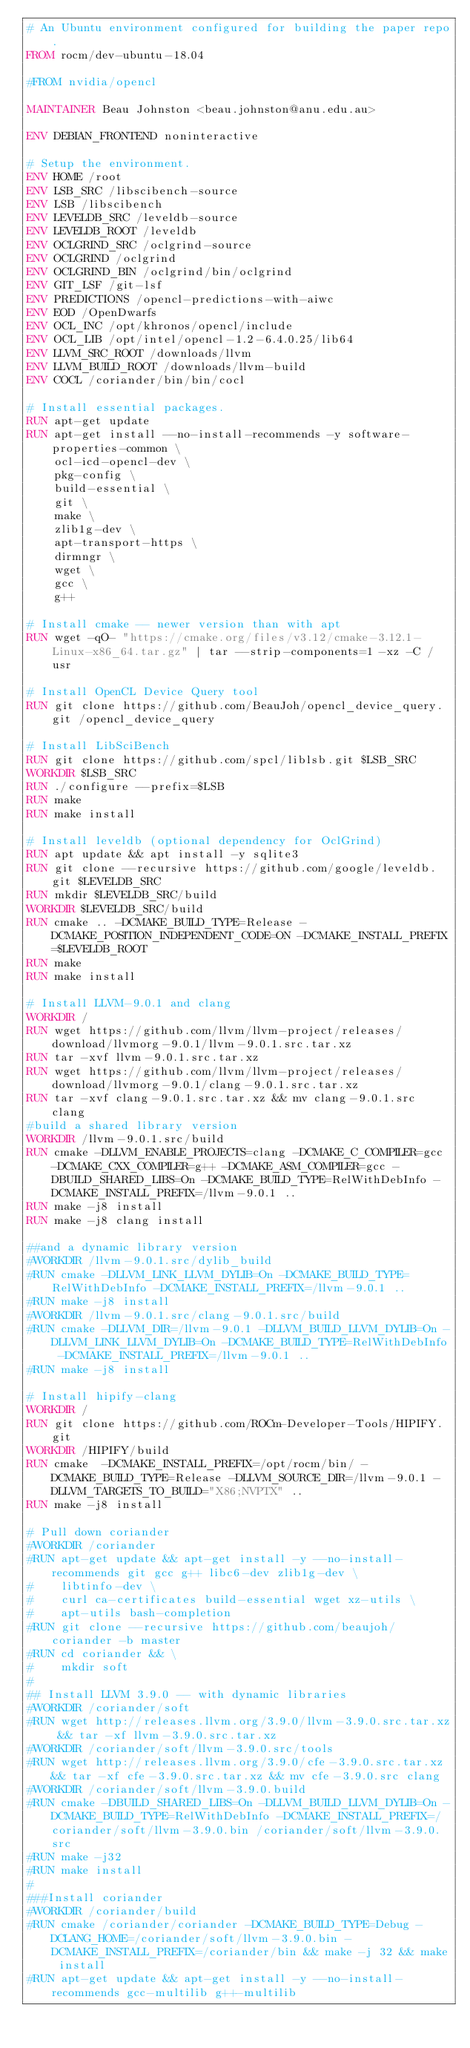<code> <loc_0><loc_0><loc_500><loc_500><_Dockerfile_># An Ubuntu environment configured for building the paper repo.
FROM rocm/dev-ubuntu-18.04

#FROM nvidia/opencl

MAINTAINER Beau Johnston <beau.johnston@anu.edu.au>

ENV DEBIAN_FRONTEND noninteractive

# Setup the environment.
ENV HOME /root
ENV LSB_SRC /libscibench-source
ENV LSB /libscibench
ENV LEVELDB_SRC /leveldb-source
ENV LEVELDB_ROOT /leveldb
ENV OCLGRIND_SRC /oclgrind-source
ENV OCLGRIND /oclgrind
ENV OCLGRIND_BIN /oclgrind/bin/oclgrind
ENV GIT_LSF /git-lsf
ENV PREDICTIONS /opencl-predictions-with-aiwc
ENV EOD /OpenDwarfs
ENV OCL_INC /opt/khronos/opencl/include
ENV OCL_LIB /opt/intel/opencl-1.2-6.4.0.25/lib64
ENV LLVM_SRC_ROOT /downloads/llvm
ENV LLVM_BUILD_ROOT /downloads/llvm-build
ENV COCL /coriander/bin/bin/cocl

# Install essential packages.
RUN apt-get update
RUN apt-get install --no-install-recommends -y software-properties-common \
    ocl-icd-opencl-dev \
    pkg-config \
    build-essential \
    git \
    make \
    zlib1g-dev \
    apt-transport-https \
    dirmngr \
    wget \
    gcc \
    g++

# Install cmake -- newer version than with apt
RUN wget -qO- "https://cmake.org/files/v3.12/cmake-3.12.1-Linux-x86_64.tar.gz" | tar --strip-components=1 -xz -C /usr

# Install OpenCL Device Query tool
RUN git clone https://github.com/BeauJoh/opencl_device_query.git /opencl_device_query

# Install LibSciBench
RUN git clone https://github.com/spcl/liblsb.git $LSB_SRC
WORKDIR $LSB_SRC
RUN ./configure --prefix=$LSB
RUN make
RUN make install

# Install leveldb (optional dependency for OclGrind)
RUN apt update && apt install -y sqlite3
RUN git clone --recursive https://github.com/google/leveldb.git $LEVELDB_SRC
RUN mkdir $LEVELDB_SRC/build
WORKDIR $LEVELDB_SRC/build
RUN cmake .. -DCMAKE_BUILD_TYPE=Release -DCMAKE_POSITION_INDEPENDENT_CODE=ON -DCMAKE_INSTALL_PREFIX=$LEVELDB_ROOT
RUN make
RUN make install

# Install LLVM-9.0.1 and clang
WORKDIR /
RUN wget https://github.com/llvm/llvm-project/releases/download/llvmorg-9.0.1/llvm-9.0.1.src.tar.xz
RUN tar -xvf llvm-9.0.1.src.tar.xz
RUN wget https://github.com/llvm/llvm-project/releases/download/llvmorg-9.0.1/clang-9.0.1.src.tar.xz
RUN tar -xvf clang-9.0.1.src.tar.xz && mv clang-9.0.1.src clang
#build a shared library version
WORKDIR /llvm-9.0.1.src/build
RUN cmake -DLLVM_ENABLE_PROJECTS=clang -DCMAKE_C_COMPILER=gcc -DCMAKE_CXX_COMPILER=g++ -DCMAKE_ASM_COMPILER=gcc -DBUILD_SHARED_LIBS=On -DCMAKE_BUILD_TYPE=RelWithDebInfo -DCMAKE_INSTALL_PREFIX=/llvm-9.0.1 ..
RUN make -j8 install
RUN make -j8 clang install

##and a dynamic library version
#WORKDIR /llvm-9.0.1.src/dylib_build
#RUN cmake -DLLVM_LINK_LLVM_DYLIB=On -DCMAKE_BUILD_TYPE=RelWithDebInfo -DCMAKE_INSTALL_PREFIX=/llvm-9.0.1 ..
#RUN make -j8 install
#WORKDIR /llvm-9.0.1.src/clang-9.0.1.src/build
#RUN cmake -DLLVM_DIR=/llvm-9.0.1 -DLLVM_BUILD_LLVM_DYLIB=On -DLLVM_LINK_LLVM_DYLIB=On -DCMAKE_BUILD_TYPE=RelWithDebInfo -DCMAKE_INSTALL_PREFIX=/llvm-9.0.1 ..
#RUN make -j8 install

# Install hipify-clang
WORKDIR /
RUN git clone https://github.com/ROCm-Developer-Tools/HIPIFY.git
WORKDIR /HIPIFY/build
RUN cmake  -DCMAKE_INSTALL_PREFIX=/opt/rocm/bin/ -DCMAKE_BUILD_TYPE=Release -DLLVM_SOURCE_DIR=/llvm-9.0.1 -DLLVM_TARGETS_TO_BUILD="X86;NVPTX" ..
RUN make -j8 install

# Pull down coriander
#WORKDIR /coriander
#RUN apt-get update && apt-get install -y --no-install-recommends git gcc g++ libc6-dev zlib1g-dev \
#    libtinfo-dev \
#    curl ca-certificates build-essential wget xz-utils \
#    apt-utils bash-completion
#RUN git clone --recursive https://github.com/beaujoh/coriander -b master
#RUN cd coriander && \
#    mkdir soft
#
## Install LLVM 3.9.0 -- with dynamic libraries
#WORKDIR /coriander/soft
#RUN wget http://releases.llvm.org/3.9.0/llvm-3.9.0.src.tar.xz && tar -xf llvm-3.9.0.src.tar.xz
#WORKDIR /coriander/soft/llvm-3.9.0.src/tools
#RUN wget http://releases.llvm.org/3.9.0/cfe-3.9.0.src.tar.xz && tar -xf cfe-3.9.0.src.tar.xz && mv cfe-3.9.0.src clang
#WORKDIR /coriander/soft/llvm-3.9.0.build
#RUN cmake -DBUILD_SHARED_LIBS=On -DLLVM_BUILD_LLVM_DYLIB=On -DCMAKE_BUILD_TYPE=RelWithDebInfo -DCMAKE_INSTALL_PREFIX=/coriander/soft/llvm-3.9.0.bin /coriander/soft/llvm-3.9.0.src
#RUN make -j32
#RUN make install
#
###Install coriander
#WORKDIR /coriander/build
#RUN cmake /coriander/coriander -DCMAKE_BUILD_TYPE=Debug -DCLANG_HOME=/coriander/soft/llvm-3.9.0.bin -DCMAKE_INSTALL_PREFIX=/coriander/bin && make -j 32 && make install
#RUN apt-get update && apt-get install -y --no-install-recommends gcc-multilib g++-multilib</code> 